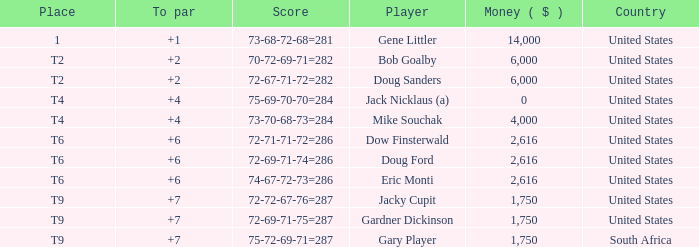What is the average To Par, when Score is "72-67-71-72=282"? 2.0. 